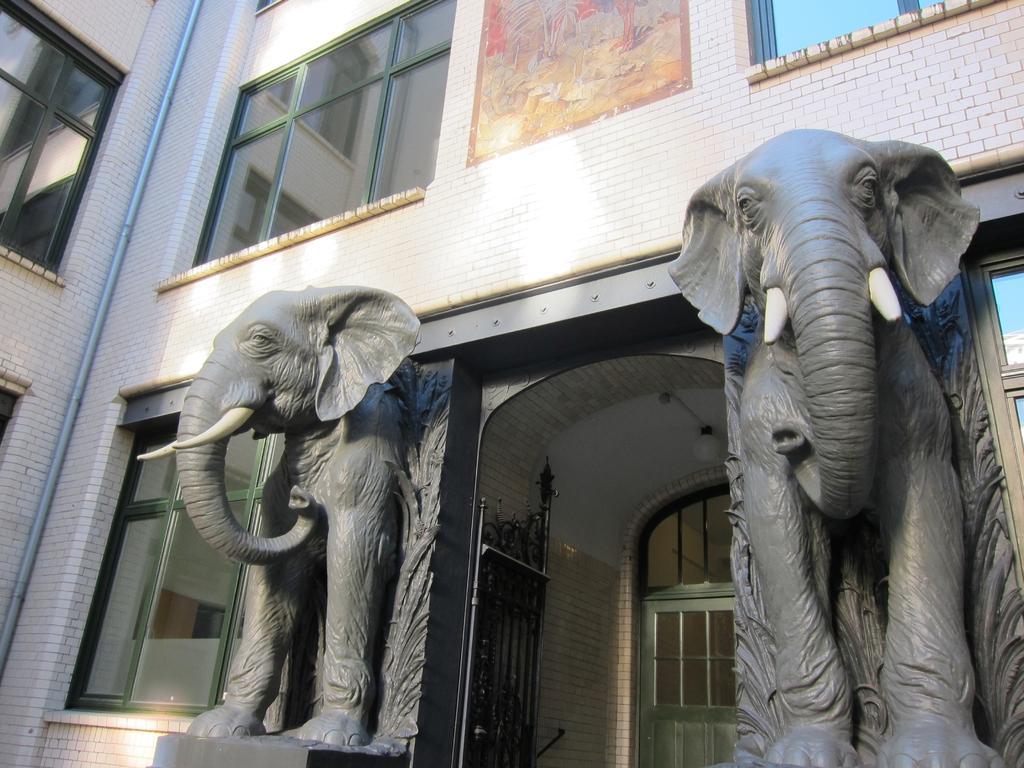How would you summarize this image in a sentence or two? The picture consists of a building. In the foreground of the picture there are statues of elephants. At the top there is brick wall. The picture has windows, pipe, gate and door. At top there is frame. 